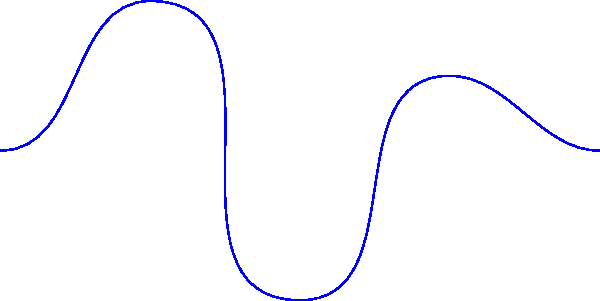As a radio broadcaster, understanding sound wave properties is crucial. The diagram shows a sound wave (blue) and its reflection (red dashed) across the time axis. How does this reflection relate to the concept of an echo, and what would be the perceived time delay between the original sound and its echo? To understand the relationship between the reflected sound wave and an echo:

1. Original wave (blue): Represents the initial sound produced.

2. Reflected wave (red dashed): Represents the echo, which is a reflection of the original sound.

3. Reflection across the time axis: This transformation simulates how sound bounces off a surface and returns to the listener.

4. Time delay calculation:
   a. The reflection effectively reverses the time axis for the wave.
   b. The total time for the echo is the time for the sound to reach the reflecting surface plus the time to return.
   c. In the diagram, the wave completes one cycle in 4 time units.
   d. The perceived delay would be 2 times the time it takes for the sound to reach the reflecting surface.
   e. Assuming the reflecting surface is at the midpoint, the delay would be 4 time units.

5. In real-world broadcasting:
   a. This concept is important for understanding room acoustics and microphone placement.
   b. Echo effects can be used creatively or need to be minimized for clear audio.

The perceived time delay between the original sound and its echo would be equal to the total width of the time axis in the diagram, which is 4 time units.
Answer: 4 time units 